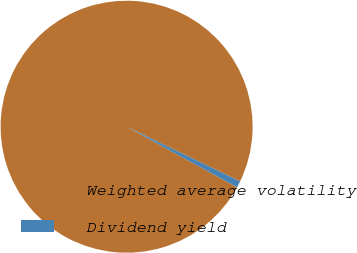Convert chart. <chart><loc_0><loc_0><loc_500><loc_500><pie_chart><fcel>Weighted average volatility<fcel>Dividend yield<nl><fcel>99.16%<fcel>0.84%<nl></chart> 